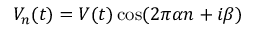Convert formula to latex. <formula><loc_0><loc_0><loc_500><loc_500>V _ { n } ( t ) = V ( t ) \cos ( 2 \pi \alpha n + i \beta )</formula> 